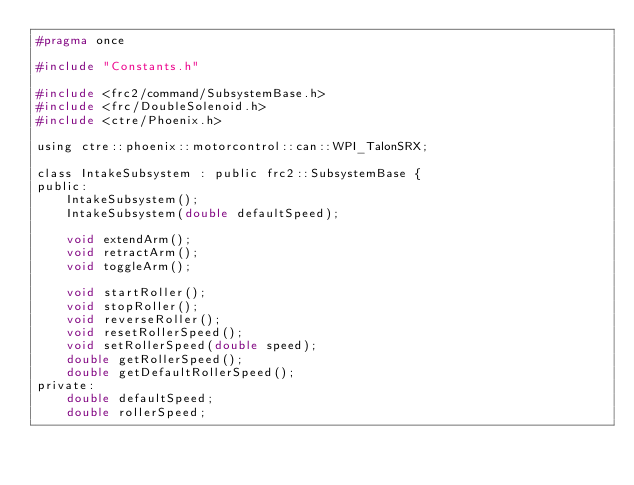<code> <loc_0><loc_0><loc_500><loc_500><_C_>#pragma once

#include "Constants.h"

#include <frc2/command/SubsystemBase.h>
#include <frc/DoubleSolenoid.h>
#include <ctre/Phoenix.h>

using ctre::phoenix::motorcontrol::can::WPI_TalonSRX;

class IntakeSubsystem : public frc2::SubsystemBase {
public:
    IntakeSubsystem();
    IntakeSubsystem(double defaultSpeed);

    void extendArm();
    void retractArm();
    void toggleArm();

    void startRoller();
    void stopRoller();
    void reverseRoller();
    void resetRollerSpeed();
    void setRollerSpeed(double speed);
    double getRollerSpeed();
    double getDefaultRollerSpeed();
private:
    double defaultSpeed;
    double rollerSpeed;
</code> 